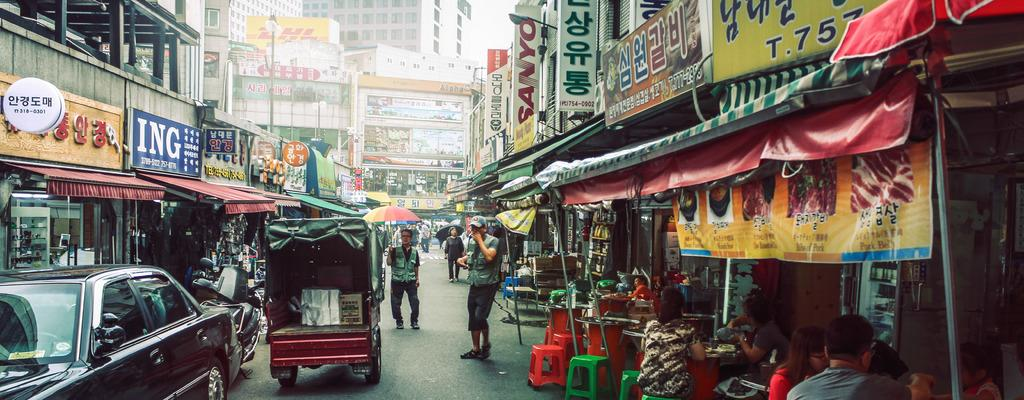What type of location is depicted in the image? The image shows a view of a market. What can be seen on either side of the market? There are shops on both sides of the market. How can one identify the specific shops in the image? There are naming boards on the shops. What can be seen in the distance behind the market? There are buildings visible in the background of the image. What type of treatment is being administered to the shape in the image? There is no shape or treatment present in the image; it depicts a view of a market with shops and buildings. 